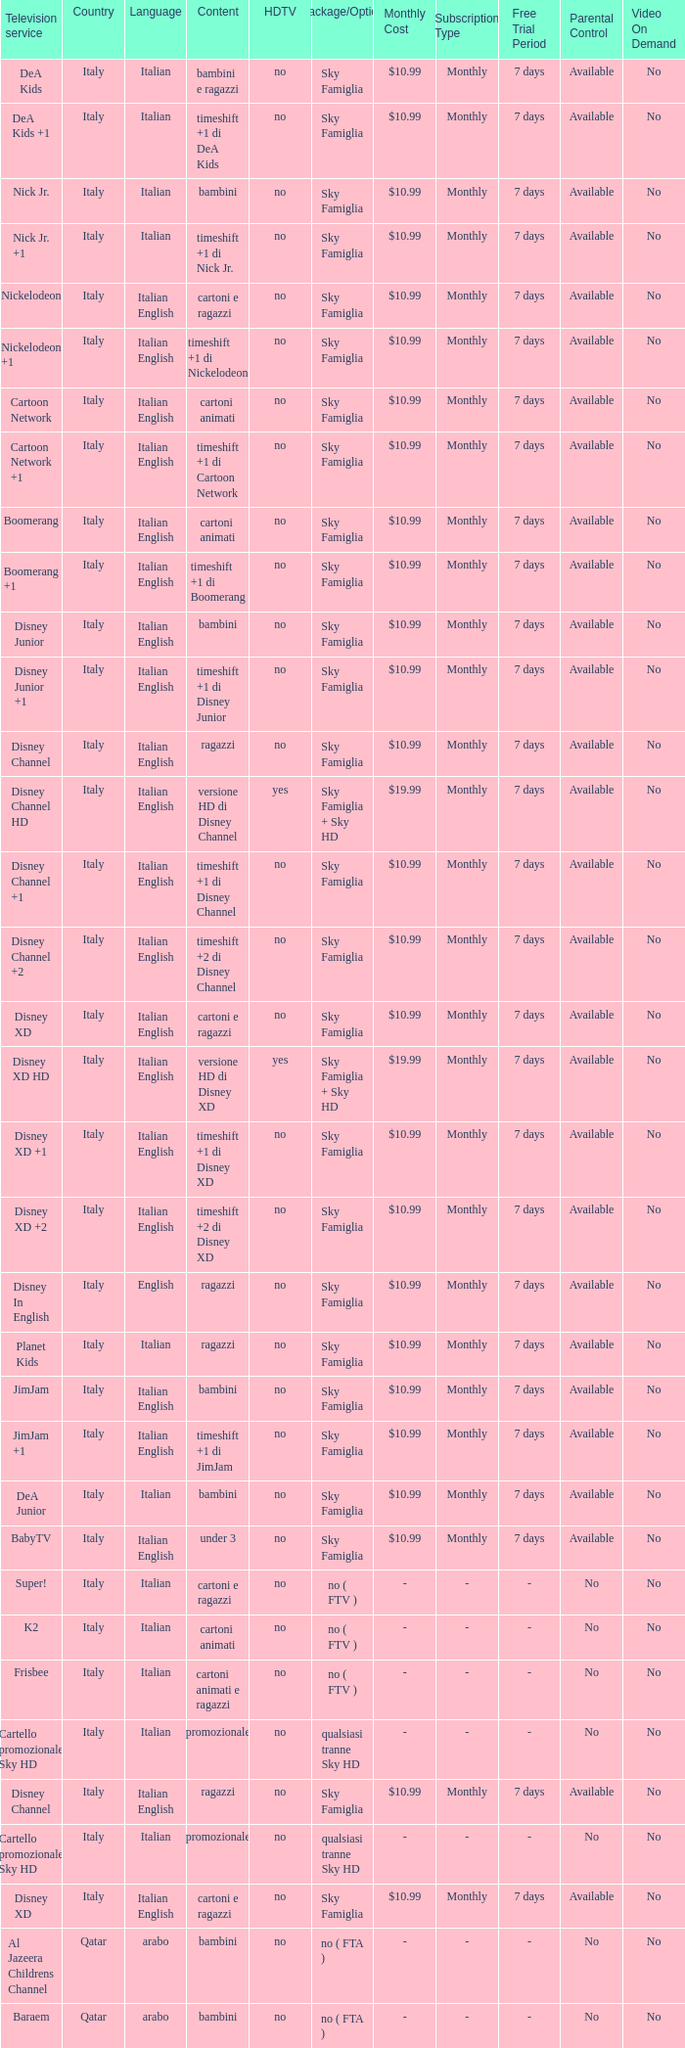What is the Country when the language is italian english, and the television service is disney xd +1? Italy. 